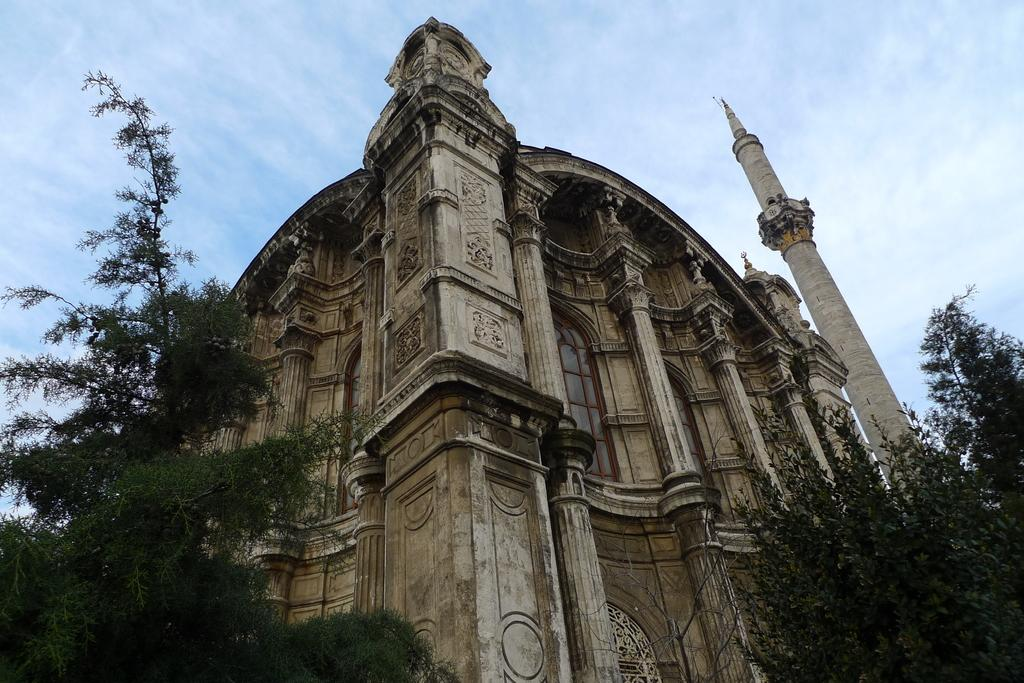What is the main subject in the center of the image? There is a building in the center of the image. What can be seen in front of the building? There are trees in front of the building. How would you describe the sky in the image? The sky is cloudy in the image. Where is the pocket located in the image? There is no pocket present in the image. Is there a jail visible in the image? There is no jail visible in the image. 